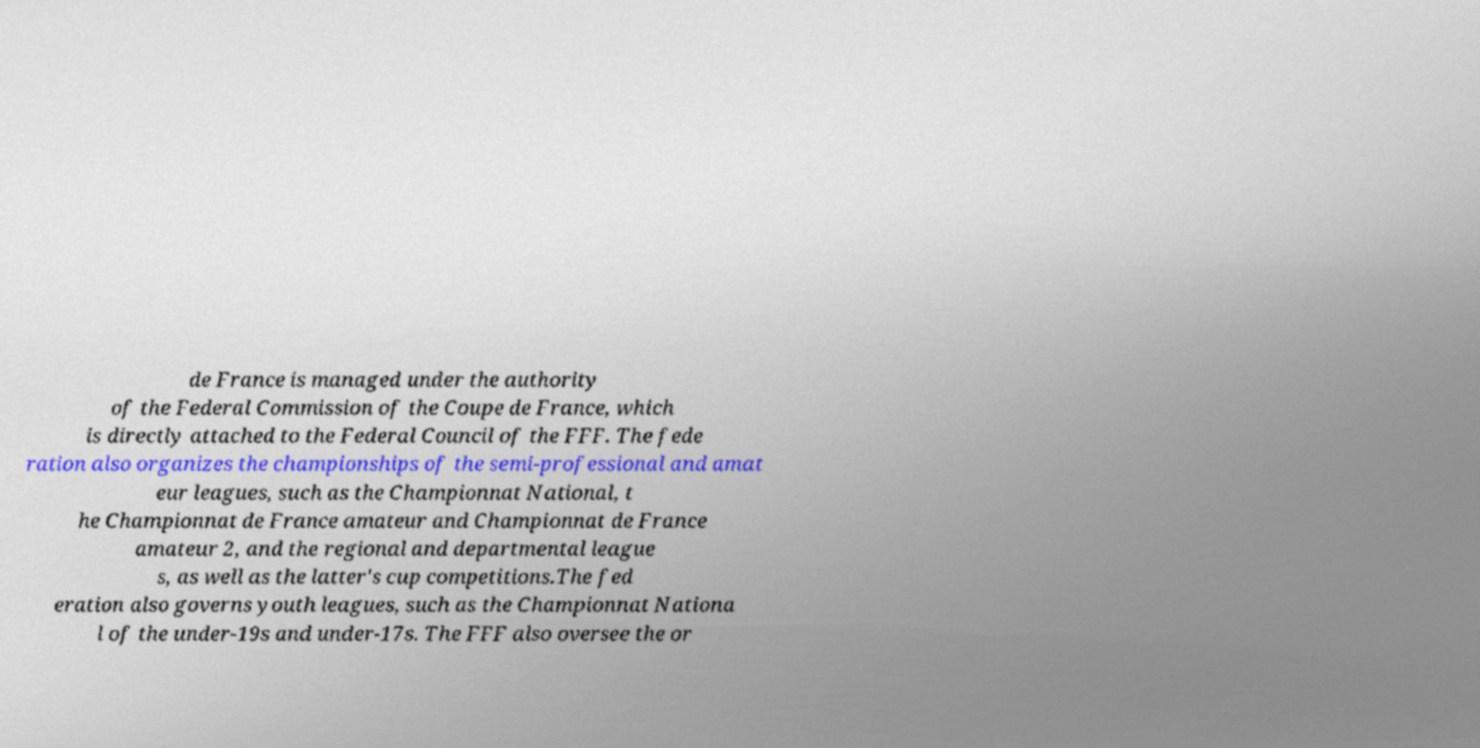Could you assist in decoding the text presented in this image and type it out clearly? de France is managed under the authority of the Federal Commission of the Coupe de France, which is directly attached to the Federal Council of the FFF. The fede ration also organizes the championships of the semi-professional and amat eur leagues, such as the Championnat National, t he Championnat de France amateur and Championnat de France amateur 2, and the regional and departmental league s, as well as the latter's cup competitions.The fed eration also governs youth leagues, such as the Championnat Nationa l of the under-19s and under-17s. The FFF also oversee the or 